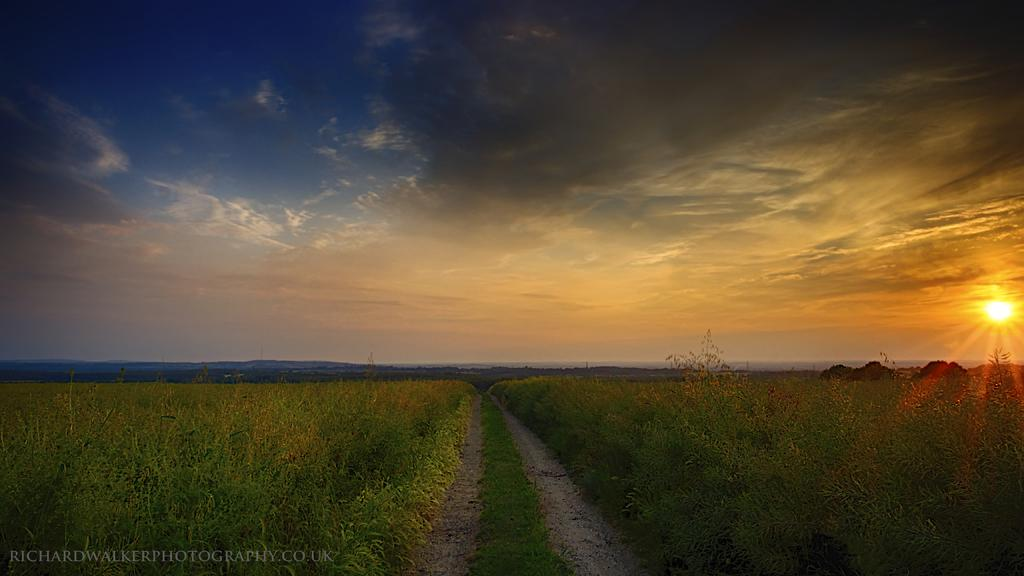What type of living organisms can be seen in the image? Plants can be seen in the image. What celestial body is visible in the image? The sun is visible in the image. What part of the natural environment is visible in the image? The sky is visible in the image. What atmospheric conditions can be observed in the image? There are clouds in the image. How many ants can be seen crawling on the window in the image? There are no ants or windows present in the image. What year is depicted in the image? The image does not depict a specific year; it is a snapshot of the natural environment. 